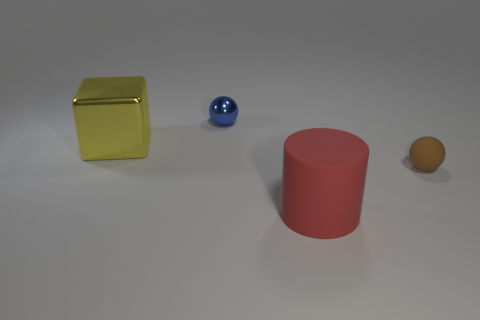Add 3 large red cubes. How many objects exist? 7 Subtract all cubes. How many objects are left? 3 Add 4 big red matte cylinders. How many big red matte cylinders are left? 5 Add 1 big green rubber objects. How many big green rubber objects exist? 1 Subtract 0 cyan blocks. How many objects are left? 4 Subtract all purple spheres. Subtract all cyan cylinders. How many spheres are left? 2 Subtract all cyan blocks. How many brown balls are left? 1 Subtract all balls. Subtract all big yellow metallic objects. How many objects are left? 1 